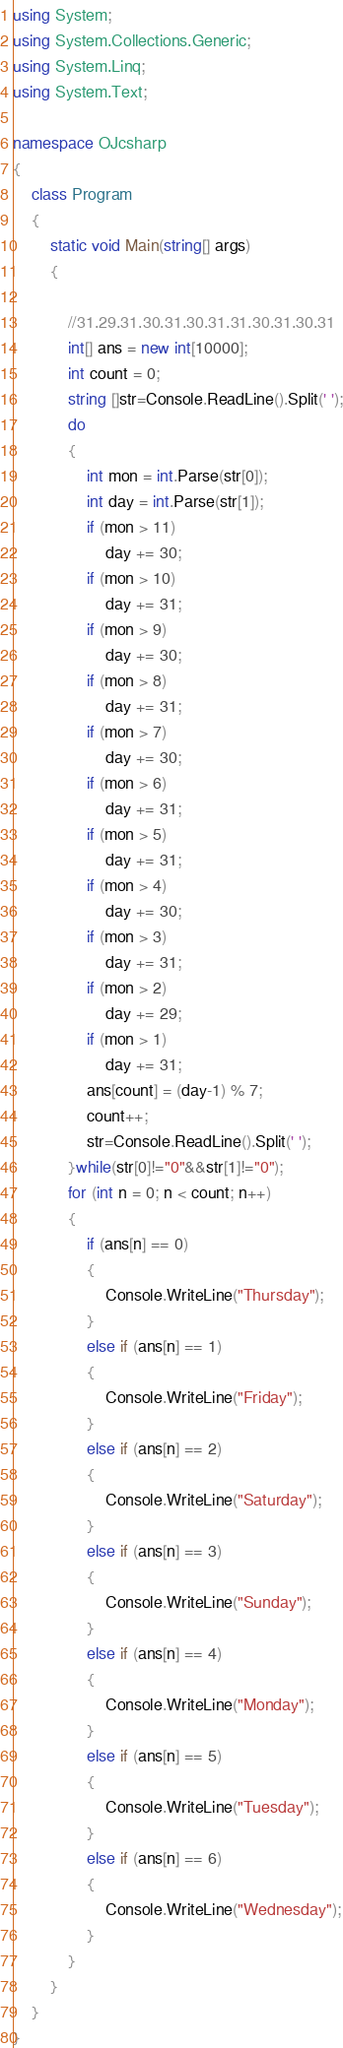Convert code to text. <code><loc_0><loc_0><loc_500><loc_500><_C#_>using System;
using System.Collections.Generic;
using System.Linq;
using System.Text;

namespace OJcsharp
{
    class Program
    {
        static void Main(string[] args)
        {

            //31.29.31.30.31.30.31.31.30.31.30.31
            int[] ans = new int[10000];
            int count = 0;
            string []str=Console.ReadLine().Split(' ');
            do
            {
                int mon = int.Parse(str[0]);
                int day = int.Parse(str[1]);
                if (mon > 11)
                    day += 30;
                if (mon > 10)
                    day += 31;
                if (mon > 9)
                    day += 30;
                if (mon > 8)
                    day += 31;
                if (mon > 7)
                    day += 30;
                if (mon > 6)
                    day += 31;
                if (mon > 5)
                    day += 31;
                if (mon > 4)
                    day += 30;
                if (mon > 3)
                    day += 31;
                if (mon > 2)
                    day += 29;
                if (mon > 1)
                    day += 31;
                ans[count] = (day-1) % 7;
                count++;
                str=Console.ReadLine().Split(' ');
            }while(str[0]!="0"&&str[1]!="0");
            for (int n = 0; n < count; n++)
            {
                if (ans[n] == 0)
                {
                    Console.WriteLine("Thursday");
                }
                else if (ans[n] == 1)
                {
                    Console.WriteLine("Friday");
                }
                else if (ans[n] == 2)
                {
                    Console.WriteLine("Saturday");
                }
                else if (ans[n] == 3)
                {
                    Console.WriteLine("Sunday");
                }
                else if (ans[n] == 4)
                {
                    Console.WriteLine("Monday");
                }
                else if (ans[n] == 5)
                {
                    Console.WriteLine("Tuesday");
                }
                else if (ans[n] == 6)
                {
                    Console.WriteLine("Wednesday");
                }
            }
        }
    }
}</code> 